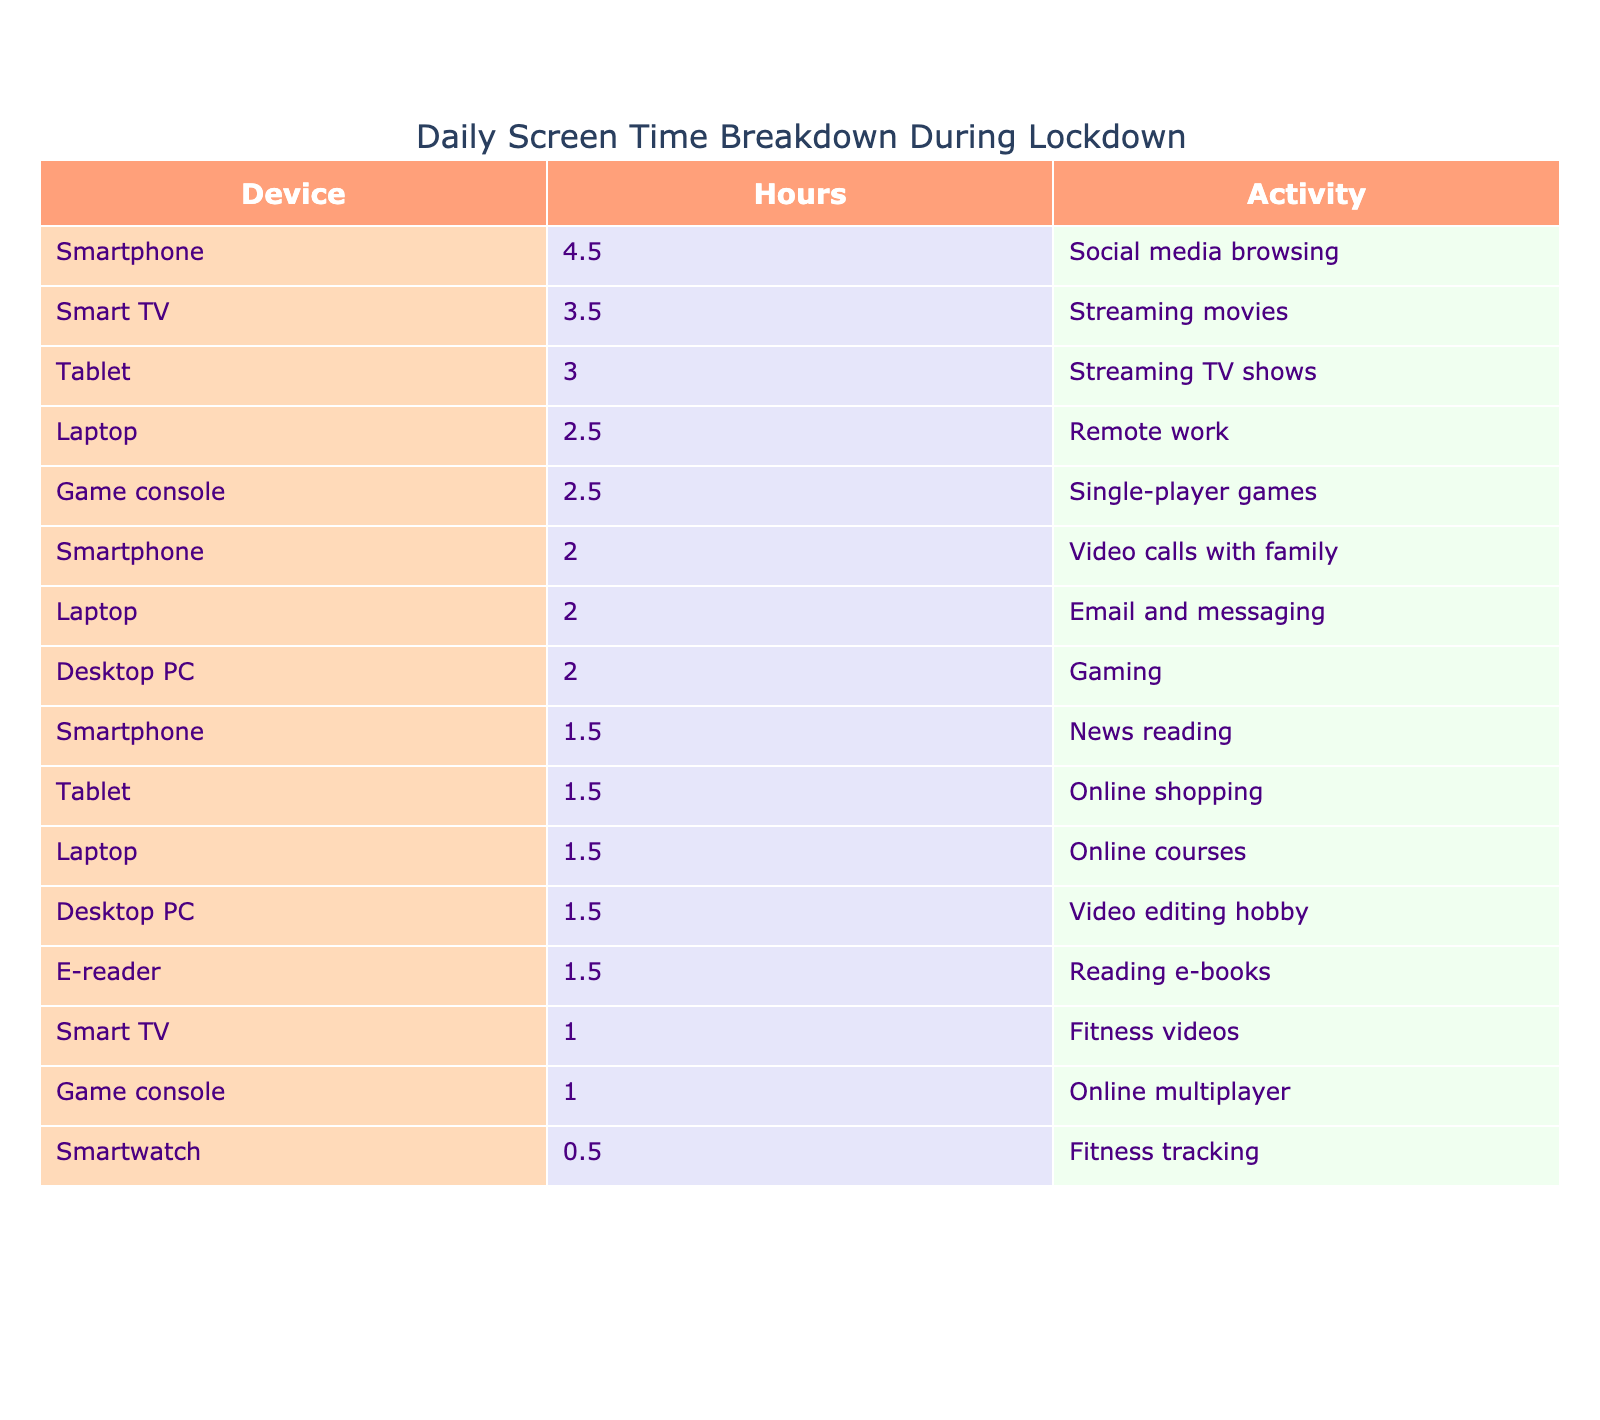What device had the highest screen time during the lockdown? Looking at the table, the device with the highest hours is the Smartphone, which had a total of 4.5 hours for social media browsing.
Answer: Smartphone How many hours did people spend on Remote work and Online courses combined? The Laptop was used for Remote work for 2.5 hours and for Online courses for 1.5 hours. The total combined hours is 2.5 + 1.5 = 4.0.
Answer: 4.0 Did people spend more time on Gaming or Fitness tracking? The Desktop PC had 2.0 hours for Gaming, and the Smartwatch had 0.5 hours for Fitness tracking. Since 2.0 > 0.5, people spent more time on Gaming.
Answer: Yes What was the total screen time for Streaming on Smart TV? For Streaming, the Smart TV had 3.5 hours for movies and 1.0 hour for fitness videos. The total is 3.5 + 1.0 = 4.5.
Answer: 4.5 Which device was used for the least amount of screen time? The Smartwatch had the least amount of screen time, with only 0.5 hours dedicated to Fitness tracking.
Answer: Smartwatch How many hours were spent on social media browsing compared to video calls? Social media browsing on the Smartphone was 4.5 hours, while video calls also on Smartphone were 2.0 hours. Therefore, 4.5 - 2.0 = 2.5 more hours were spent on social media.
Answer: 2.5 What is the average screen time across all devices? To find the average, sum all hours: 4.5 + 2.0 + 1.5 + 3.0 + 1.5 + 2.5 + 1.5 + 2.0 + 3.5 + 1.0 + 2.0 + 1.5 + 2.5 + 1.0 + 1.5 + 0.5 = 27.0 hours. There are 15 devices, so the average is 27.0 / 15 = 1.8 hours.
Answer: 1.8 How many devices had screen time greater than 2 hours? Devices with screen time greater than 2 hours are Smartphone (4.5), Tablet (3.0), Laptop (2.5), Smart TV (3.5), Desktop PC (2.0), and Game console (2.5). Counting these, we find there are 6 devices.
Answer: 6 Was more time spent on Streaming TV shows than on Video calls? Streaming TV shows on the Tablet took 3.0 hours, while Video calls were 2.0 hours on the Smartphone. Since 3.0 > 2.0, more time was spent on Streaming TV shows.
Answer: Yes What was the combined screen time for the Tablet and Smart TV activities? The Tablet had a total screen time of 4.5 hours (3.0 for Streaming TV shows + 1.5 for Online shopping), and the Smart TV had 4.5 hours (3.5 for Streaming movies + 1.0 for Fitness videos). Combining these gives 4.5 + 4.5 = 9.0 hours.
Answer: 9.0 